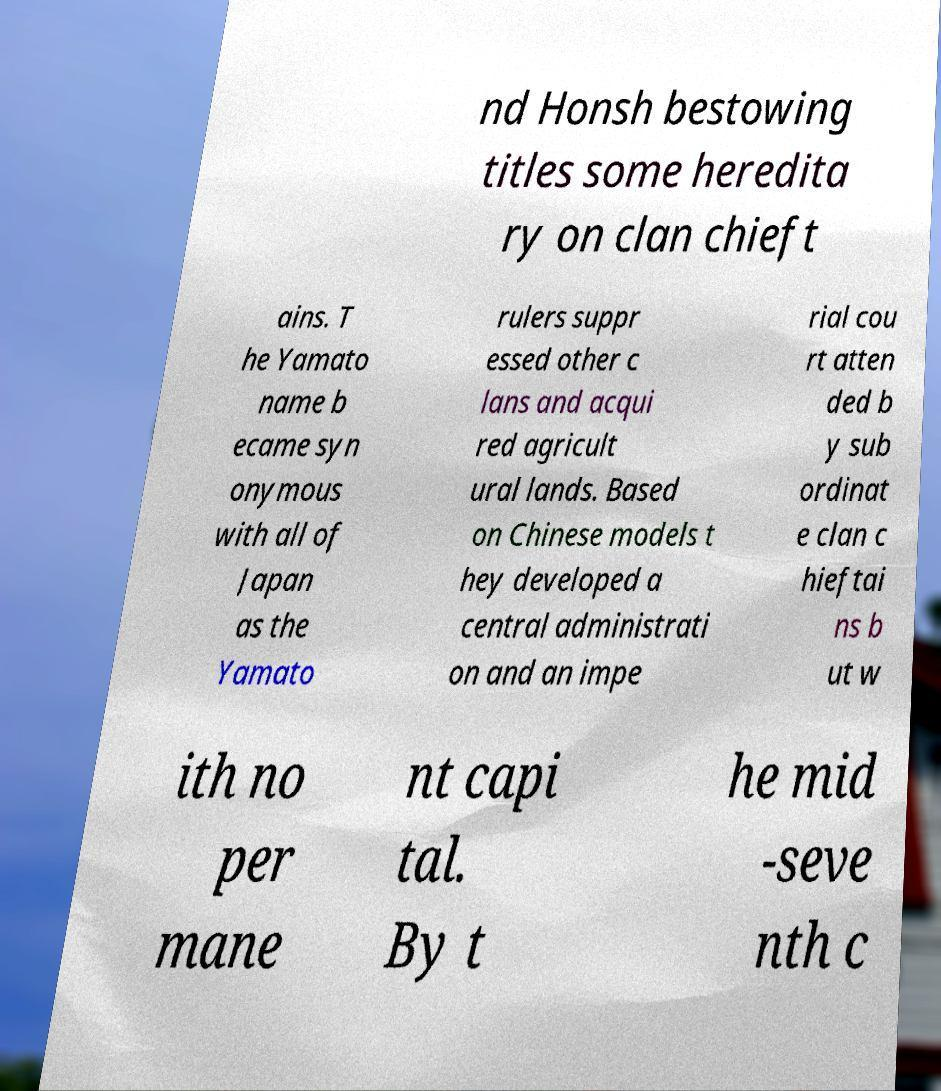Can you read and provide the text displayed in the image?This photo seems to have some interesting text. Can you extract and type it out for me? nd Honsh bestowing titles some heredita ry on clan chieft ains. T he Yamato name b ecame syn onymous with all of Japan as the Yamato rulers suppr essed other c lans and acqui red agricult ural lands. Based on Chinese models t hey developed a central administrati on and an impe rial cou rt atten ded b y sub ordinat e clan c hieftai ns b ut w ith no per mane nt capi tal. By t he mid -seve nth c 